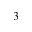<formula> <loc_0><loc_0><loc_500><loc_500>_ { 3 }</formula> 